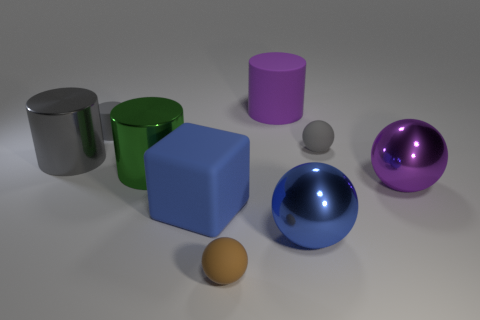How many gray cylinders must be subtracted to get 1 gray cylinders? 1 Subtract all purple cylinders. How many cylinders are left? 3 Subtract all cubes. How many objects are left? 8 Add 6 brown spheres. How many brown spheres exist? 7 Add 1 large green metallic objects. How many objects exist? 10 Subtract all tiny gray rubber spheres. How many spheres are left? 3 Subtract 1 brown balls. How many objects are left? 8 Subtract 3 cylinders. How many cylinders are left? 1 Subtract all brown cylinders. Subtract all yellow balls. How many cylinders are left? 4 Subtract all green cylinders. How many cyan balls are left? 0 